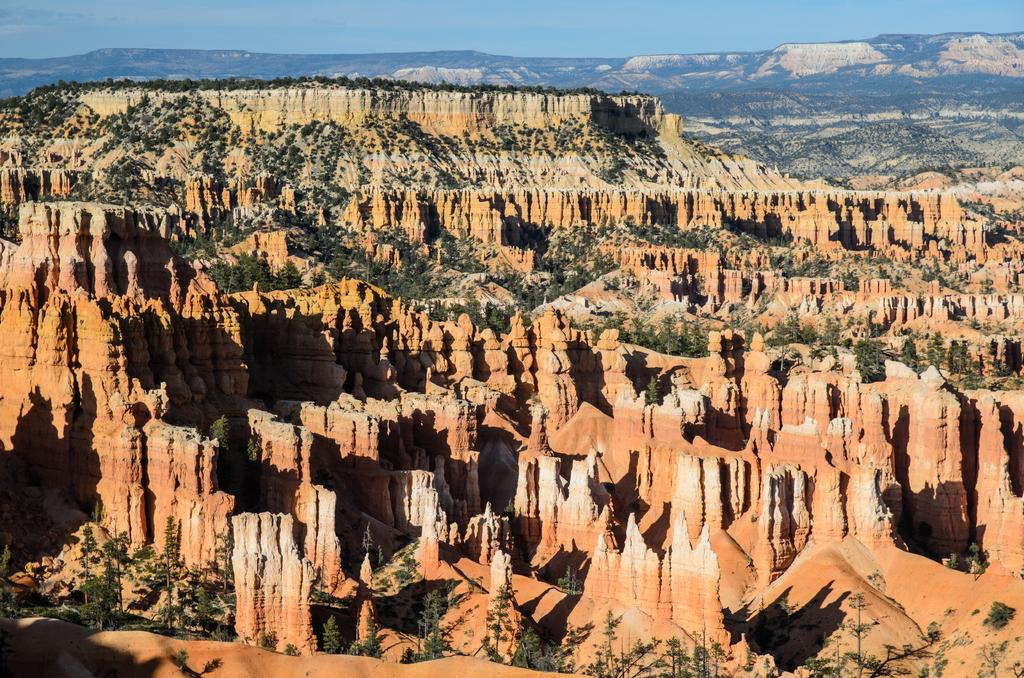What location is depicted in the image? The image depicts Bryce Canyon National Park. What type of vegetation can be seen in the park? Trees and plants are present in the park. What type of vase can be seen on the table in the image? There is no vase or table present in the image; it depicts Bryce Canyon National Park. 